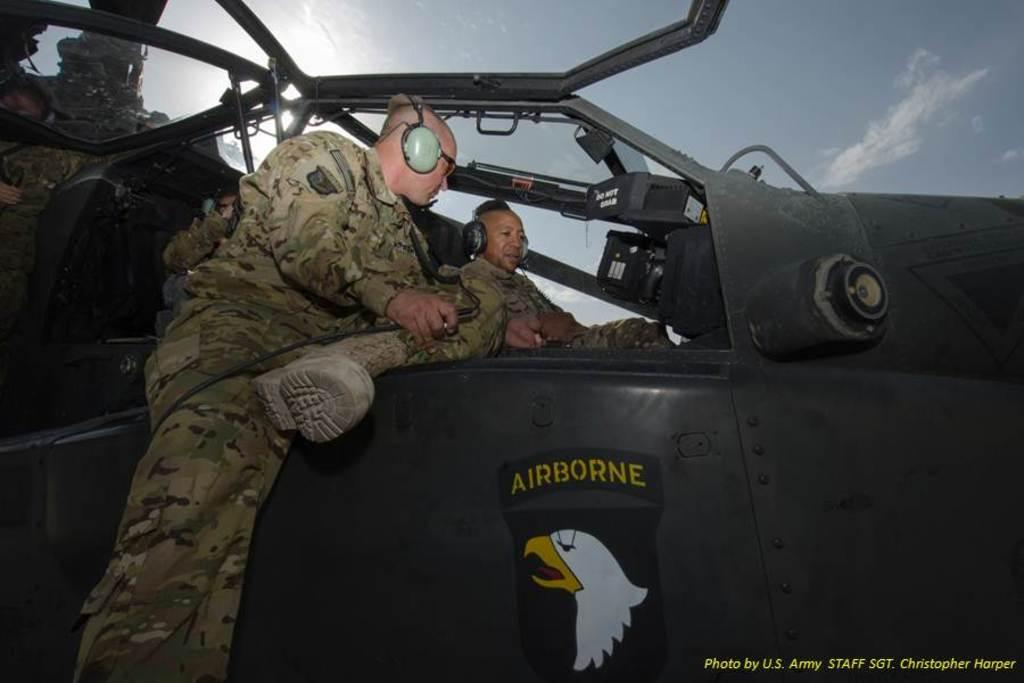Provide a one-sentence caption for the provided image. Two pilots talking in the cockpit of a helicopter with "Airborne" written on the side. 